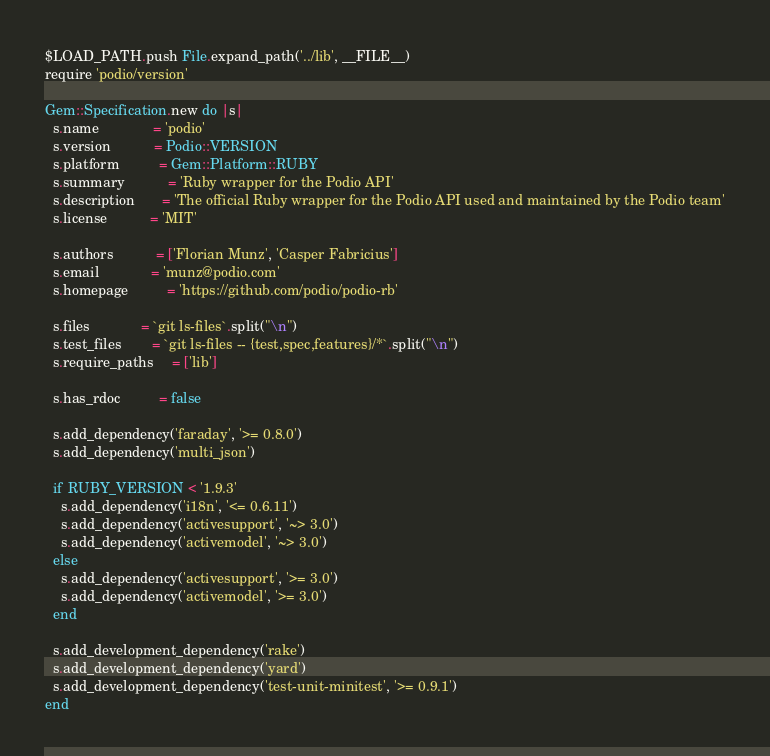Convert code to text. <code><loc_0><loc_0><loc_500><loc_500><_Ruby_>$LOAD_PATH.push File.expand_path('../lib', __FILE__)
require 'podio/version'

Gem::Specification.new do |s|
  s.name              = 'podio'
  s.version           = Podio::VERSION
  s.platform          = Gem::Platform::RUBY
  s.summary           = 'Ruby wrapper for the Podio API'
  s.description       = 'The official Ruby wrapper for the Podio API used and maintained by the Podio team'
  s.license           = 'MIT'

  s.authors           = ['Florian Munz', 'Casper Fabricius']
  s.email             = 'munz@podio.com'
  s.homepage          = 'https://github.com/podio/podio-rb'

  s.files             = `git ls-files`.split("\n")
  s.test_files        = `git ls-files -- {test,spec,features}/*`.split("\n")
  s.require_paths     = ['lib']

  s.has_rdoc          = false

  s.add_dependency('faraday', '>= 0.8.0')
  s.add_dependency('multi_json')

  if RUBY_VERSION < '1.9.3'
    s.add_dependency('i18n', '<= 0.6.11')
    s.add_dependency('activesupport', '~> 3.0')
    s.add_dependency('activemodel', '~> 3.0')
  else
    s.add_dependency('activesupport', '>= 3.0')
    s.add_dependency('activemodel', '>= 3.0')
  end

  s.add_development_dependency('rake')
  s.add_development_dependency('yard')
  s.add_development_dependency('test-unit-minitest', '>= 0.9.1')
end
</code> 